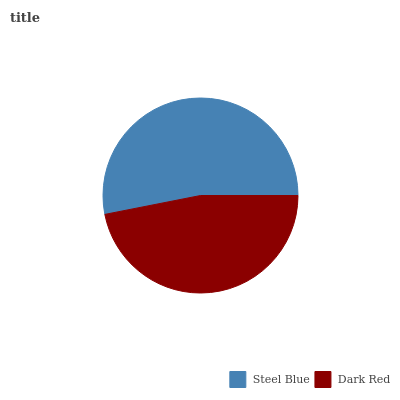Is Dark Red the minimum?
Answer yes or no. Yes. Is Steel Blue the maximum?
Answer yes or no. Yes. Is Dark Red the maximum?
Answer yes or no. No. Is Steel Blue greater than Dark Red?
Answer yes or no. Yes. Is Dark Red less than Steel Blue?
Answer yes or no. Yes. Is Dark Red greater than Steel Blue?
Answer yes or no. No. Is Steel Blue less than Dark Red?
Answer yes or no. No. Is Steel Blue the high median?
Answer yes or no. Yes. Is Dark Red the low median?
Answer yes or no. Yes. Is Dark Red the high median?
Answer yes or no. No. Is Steel Blue the low median?
Answer yes or no. No. 